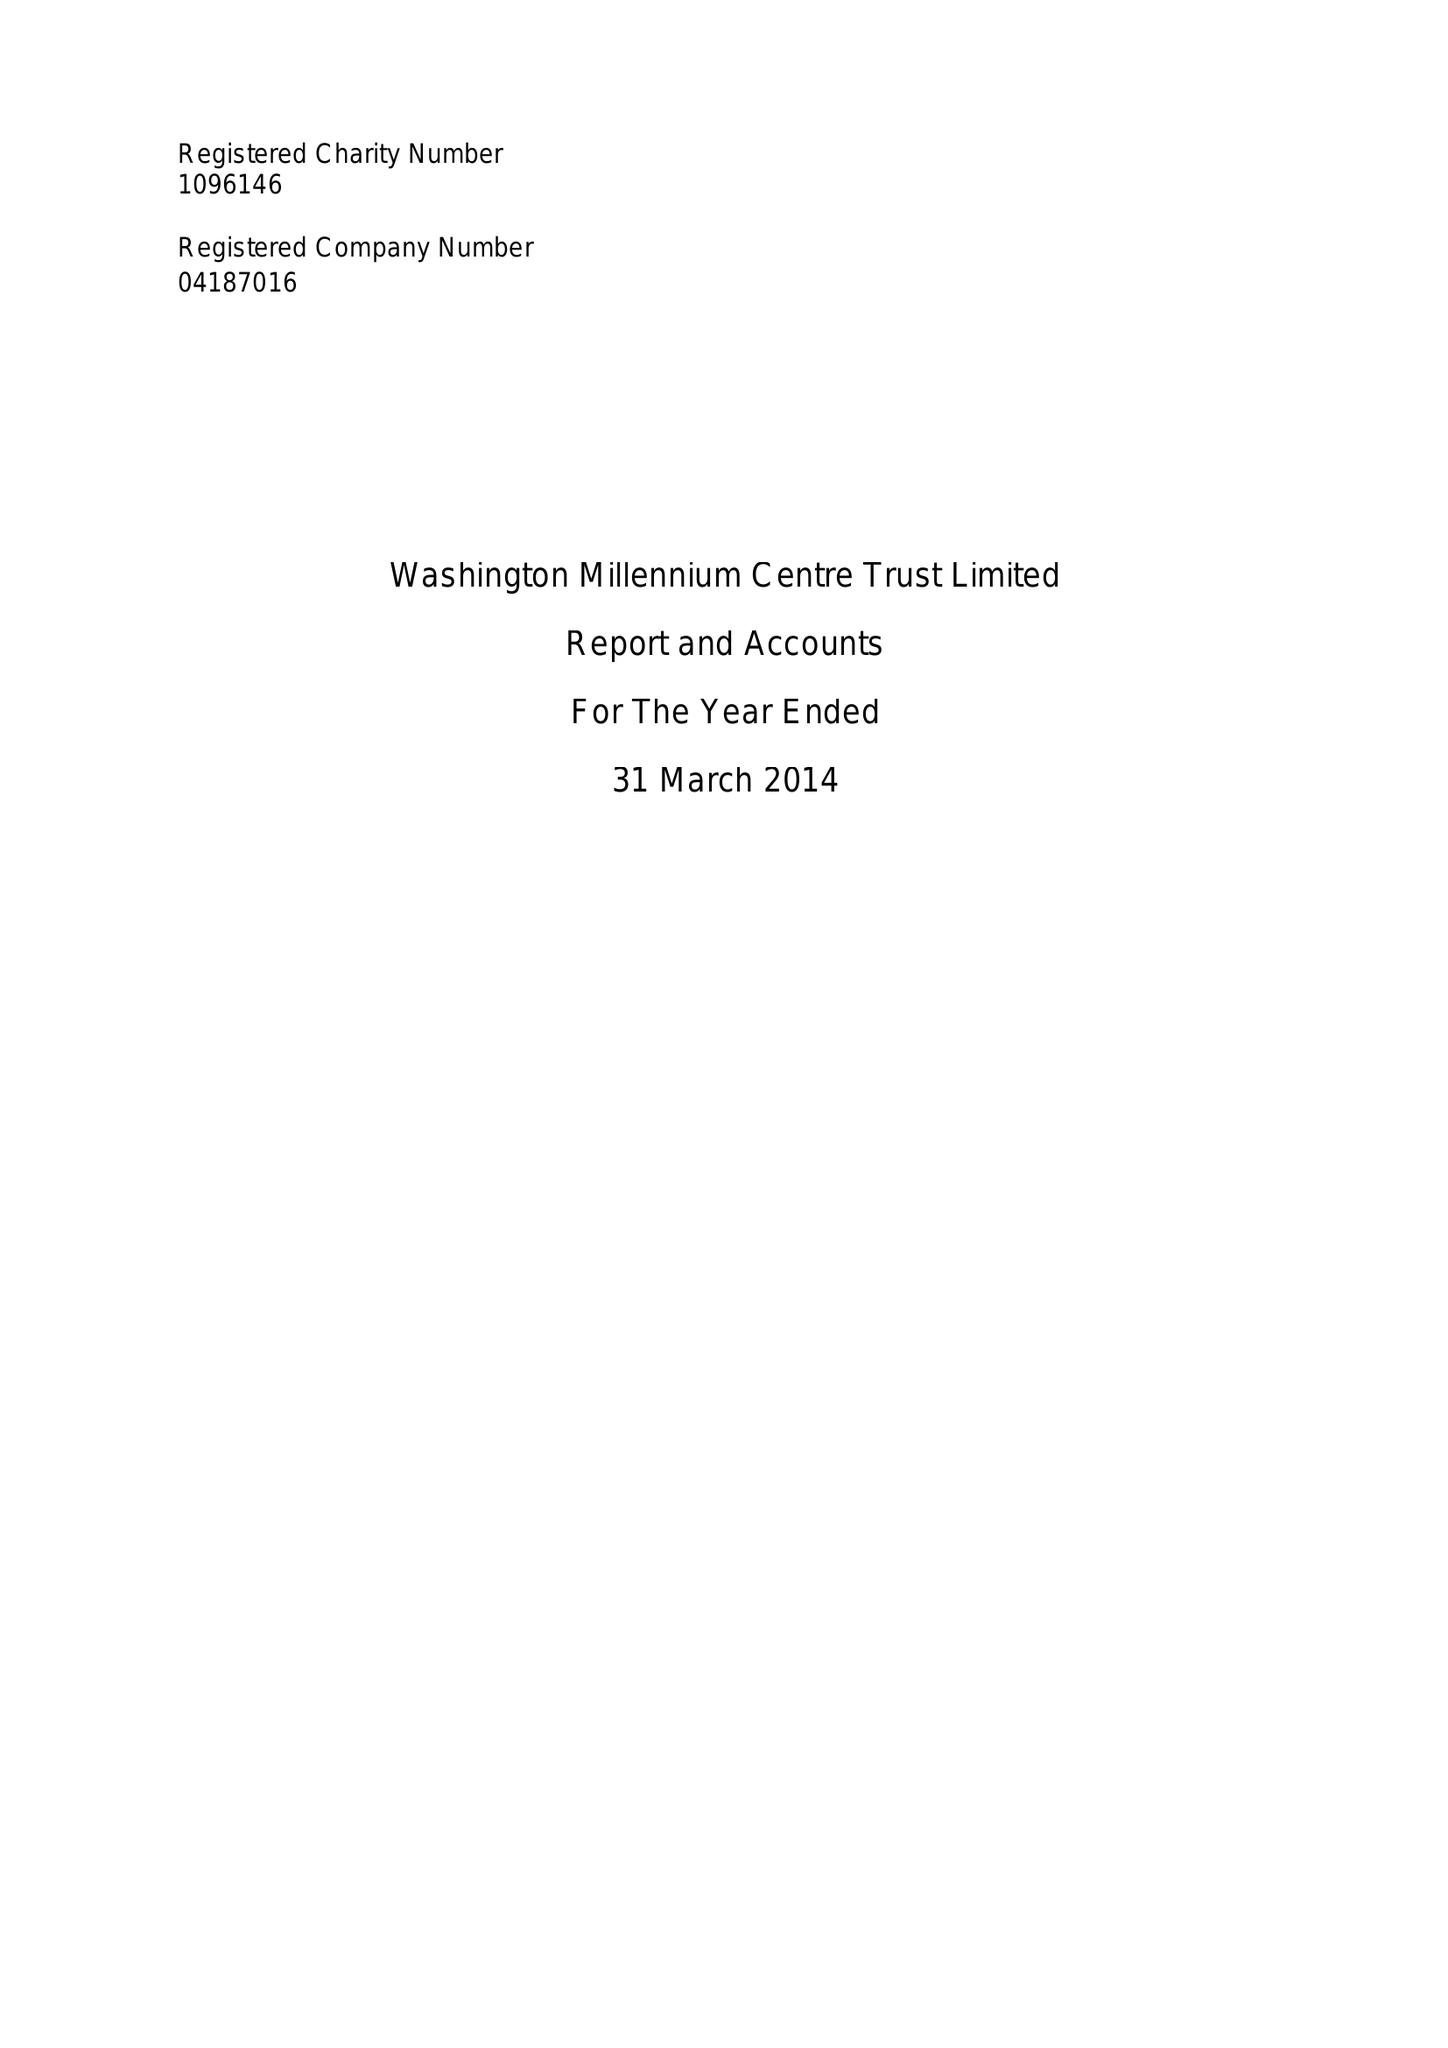What is the value for the charity_name?
Answer the question using a single word or phrase. Washington Millennium Centre Trust Ltd. 